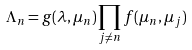<formula> <loc_0><loc_0><loc_500><loc_500>\Lambda _ { n } = g ( \lambda , \mu _ { n } ) \prod _ { j \neq n } f ( \mu _ { n } , \mu _ { j } )</formula> 